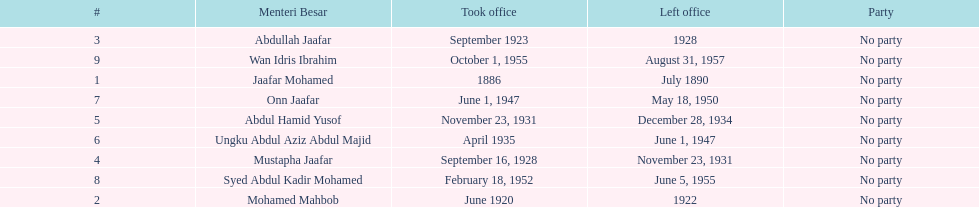Who is listed below onn jaafar? Syed Abdul Kadir Mohamed. 